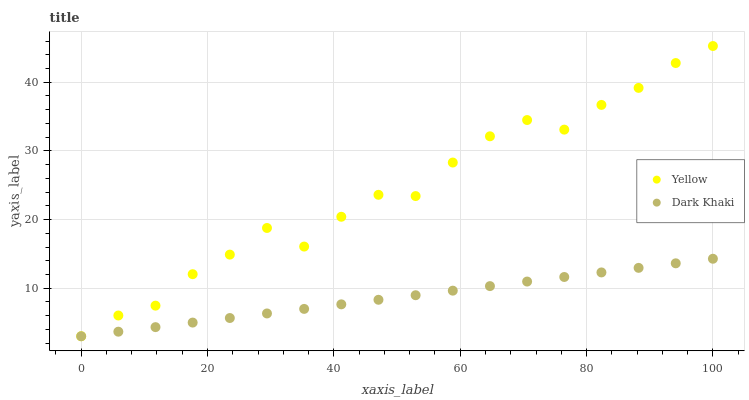Does Dark Khaki have the minimum area under the curve?
Answer yes or no. Yes. Does Yellow have the maximum area under the curve?
Answer yes or no. Yes. Does Yellow have the minimum area under the curve?
Answer yes or no. No. Is Dark Khaki the smoothest?
Answer yes or no. Yes. Is Yellow the roughest?
Answer yes or no. Yes. Is Yellow the smoothest?
Answer yes or no. No. Does Dark Khaki have the lowest value?
Answer yes or no. Yes. Does Yellow have the highest value?
Answer yes or no. Yes. Does Dark Khaki intersect Yellow?
Answer yes or no. Yes. Is Dark Khaki less than Yellow?
Answer yes or no. No. Is Dark Khaki greater than Yellow?
Answer yes or no. No. 